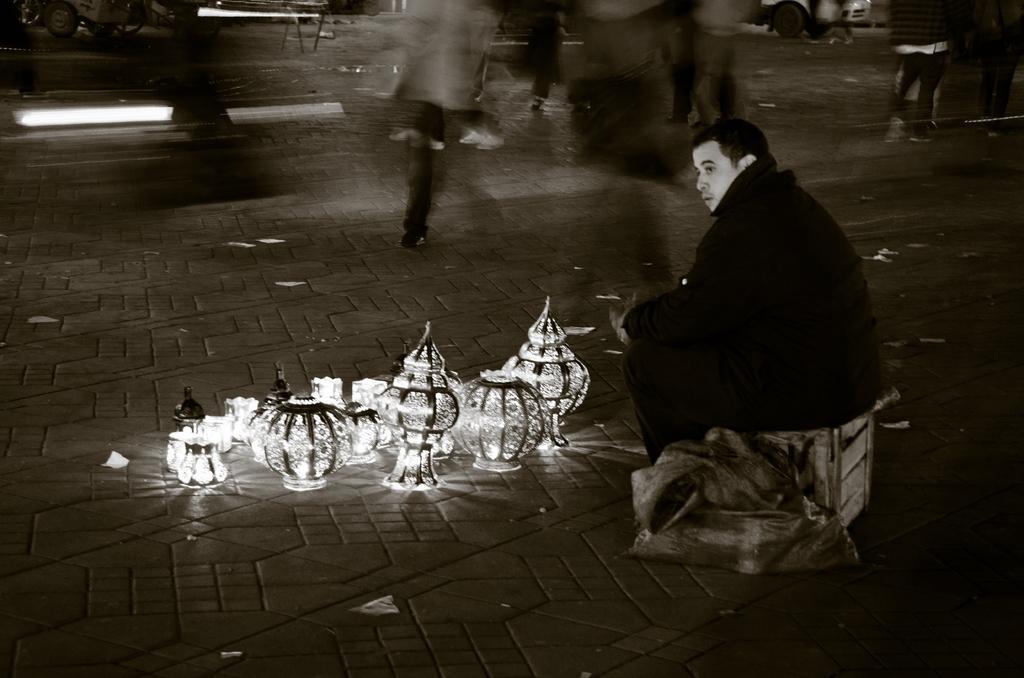How would you summarize this image in a sentence or two? In the image there is a man sitting on a wooden box and in front of him there are some objects kept on a platform and the background of the picture is blur. 